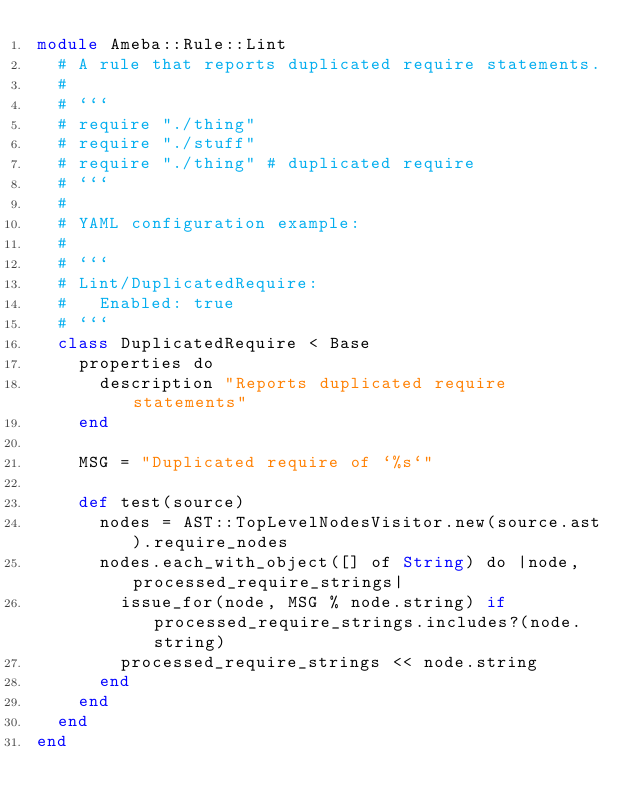<code> <loc_0><loc_0><loc_500><loc_500><_Crystal_>module Ameba::Rule::Lint
  # A rule that reports duplicated require statements.
  #
  # ```
  # require "./thing"
  # require "./stuff"
  # require "./thing" # duplicated require
  # ```
  #
  # YAML configuration example:
  #
  # ```
  # Lint/DuplicatedRequire:
  #   Enabled: true
  # ```
  class DuplicatedRequire < Base
    properties do
      description "Reports duplicated require statements"
    end

    MSG = "Duplicated require of `%s`"

    def test(source)
      nodes = AST::TopLevelNodesVisitor.new(source.ast).require_nodes
      nodes.each_with_object([] of String) do |node, processed_require_strings|
        issue_for(node, MSG % node.string) if processed_require_strings.includes?(node.string)
        processed_require_strings << node.string
      end
    end
  end
end
</code> 